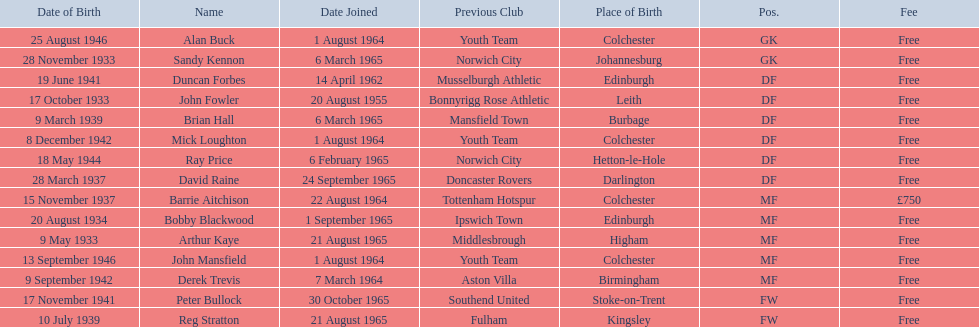What is the date of the lst player that joined? 20 August 1955. 